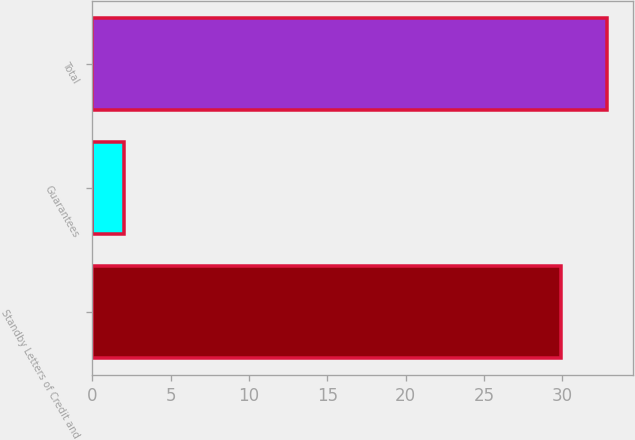Convert chart to OTSL. <chart><loc_0><loc_0><loc_500><loc_500><bar_chart><fcel>Standby Letters of Credit and<fcel>Guarantees<fcel>Total<nl><fcel>29.9<fcel>2<fcel>32.89<nl></chart> 